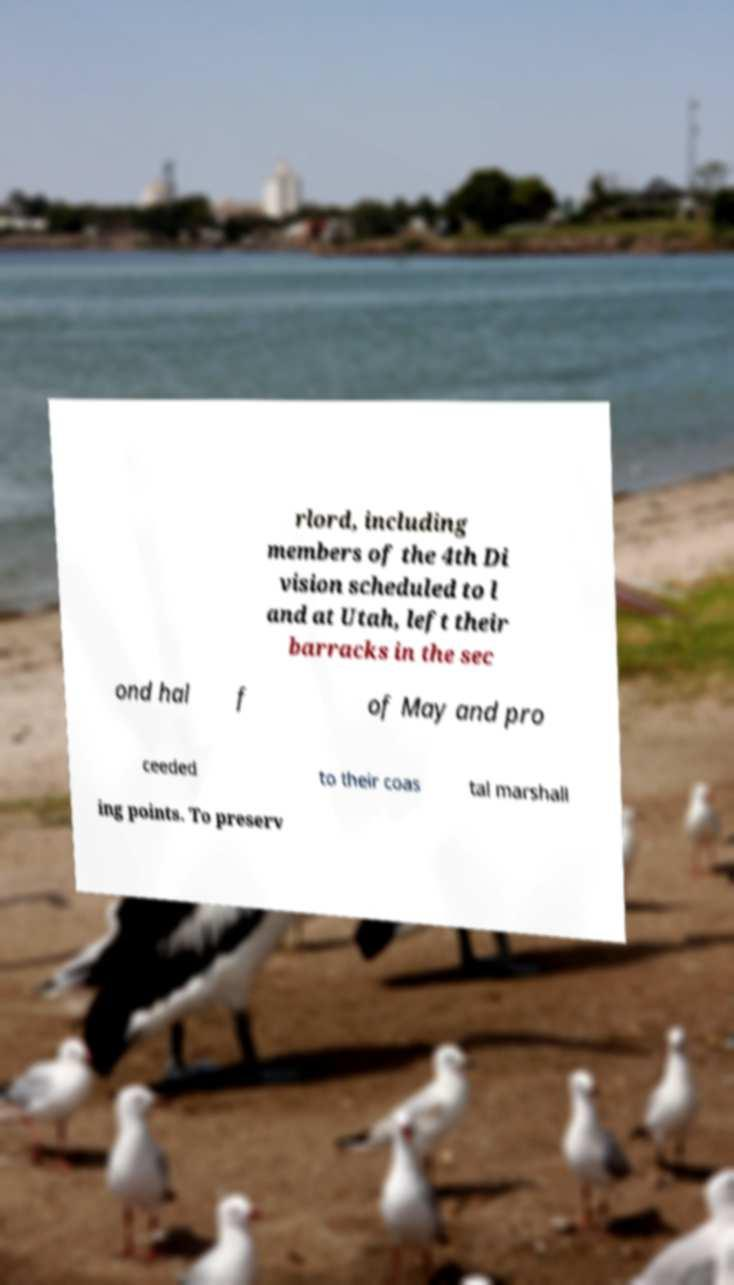Could you assist in decoding the text presented in this image and type it out clearly? rlord, including members of the 4th Di vision scheduled to l and at Utah, left their barracks in the sec ond hal f of May and pro ceeded to their coas tal marshall ing points. To preserv 